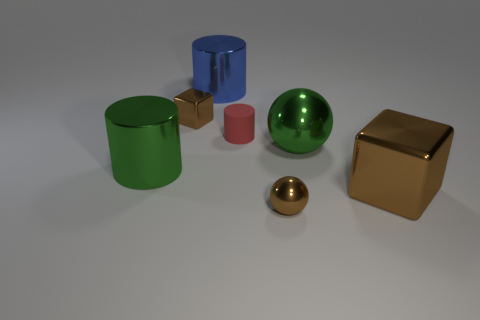Subtract all big cylinders. How many cylinders are left? 1 Subtract all blue cylinders. How many cylinders are left? 2 Add 2 metallic blocks. How many objects exist? 9 Subtract all blocks. How many objects are left? 5 Subtract 1 spheres. How many spheres are left? 1 Add 2 small blue cubes. How many small blue cubes exist? 2 Subtract 1 brown cubes. How many objects are left? 6 Subtract all blue cubes. Subtract all blue balls. How many cubes are left? 2 Subtract all brown shiny blocks. Subtract all large gray matte spheres. How many objects are left? 5 Add 7 large green shiny spheres. How many large green shiny spheres are left? 8 